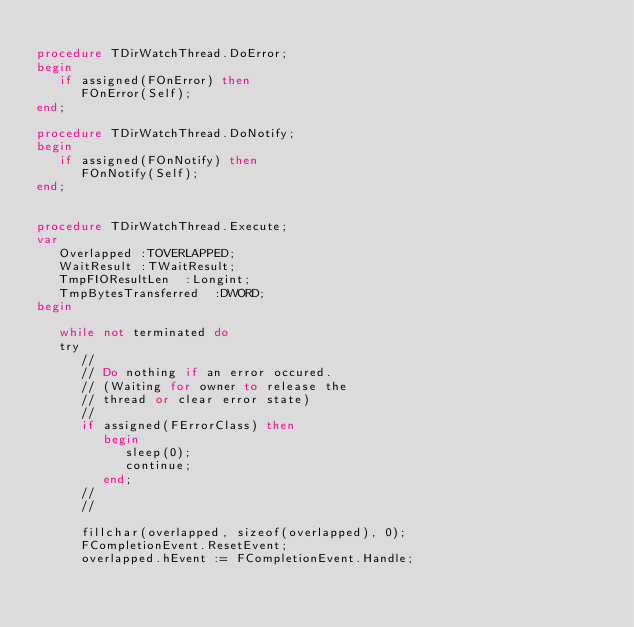<code> <loc_0><loc_0><loc_500><loc_500><_Pascal_>
procedure TDirWatchThread.DoError;
begin
   if assigned(FOnError) then
      FOnError(Self);
end;

procedure TDirWatchThread.DoNotify;
begin
   if assigned(FOnNotify) then
      FOnNotify(Self);
end;


procedure TDirWatchThread.Execute;
var
   Overlapped :TOVERLAPPED;
   WaitResult :TWaitResult;
   TmpFIOResultLen  :Longint;
   TmpBytesTransferred  :DWORD;
begin

   while not terminated do
   try
      //
      // Do nothing if an error occured.
      // (Waiting for owner to release the
      // thread or clear error state)
      //
      if assigned(FErrorClass) then
         begin
            sleep(0);
            continue;
         end;
      //
      //

      fillchar(overlapped, sizeof(overlapped), 0);
      FCompletionEvent.ResetEvent;
      overlapped.hEvent := FCompletionEvent.Handle;
</code> 